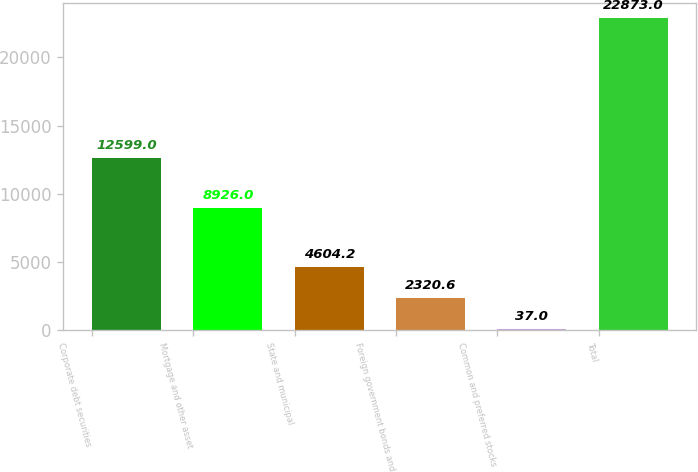Convert chart to OTSL. <chart><loc_0><loc_0><loc_500><loc_500><bar_chart><fcel>Corporate debt securities<fcel>Mortgage and other asset<fcel>State and municipal<fcel>Foreign government bonds and<fcel>Common and preferred stocks<fcel>Total<nl><fcel>12599<fcel>8926<fcel>4604.2<fcel>2320.6<fcel>37<fcel>22873<nl></chart> 